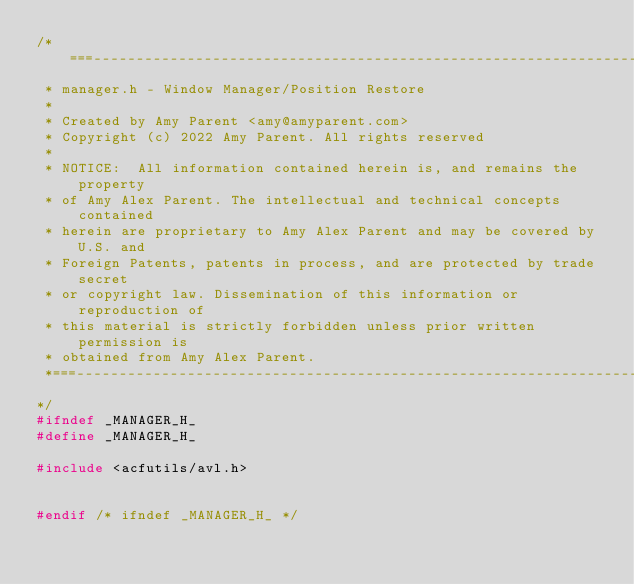Convert code to text. <code><loc_0><loc_0><loc_500><loc_500><_C_>/*===--------------------------------------------------------------------------------------------===
 * manager.h - Window Manager/Position Restore
 *
 * Created by Amy Parent <amy@amyparent.com>
 * Copyright (c) 2022 Amy Parent. All rights reserved
 *
 * NOTICE:  All information contained herein is, and remains the property
 * of Amy Alex Parent. The intellectual and technical concepts contained
 * herein are proprietary to Amy Alex Parent and may be covered by U.S. and
 * Foreign Patents, patents in process, and are protected by trade secret
 * or copyright law. Dissemination of this information or reproduction of
 * this material is strictly forbidden unless prior written permission is
 * obtained from Amy Alex Parent.
 *===--------------------------------------------------------------------------------------------===
*/
#ifndef _MANAGER_H_
#define _MANAGER_H_

#include <acfutils/avl.h>


#endif /* ifndef _MANAGER_H_ */

</code> 